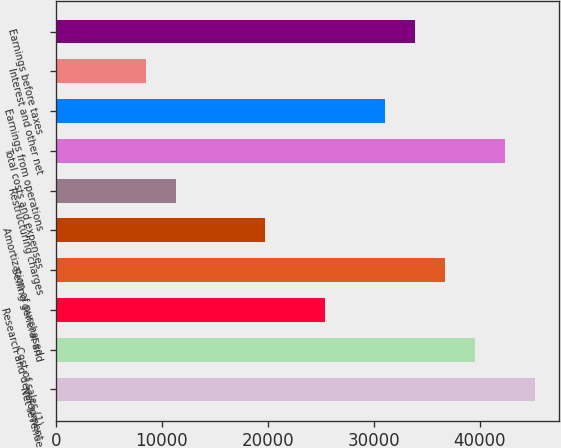Convert chart. <chart><loc_0><loc_0><loc_500><loc_500><bar_chart><fcel>Net revenue<fcel>Cost of sales (1)<fcel>Research and development<fcel>Selling general and<fcel>Amortization of purchased<fcel>Restructuring charges<fcel>Total costs and expenses<fcel>Earnings from operations<fcel>Interest and other net<fcel>Earnings before taxes<nl><fcel>45219.1<fcel>39566.7<fcel>25435.8<fcel>36740.6<fcel>19783.4<fcel>11304.8<fcel>42392.9<fcel>31088.2<fcel>8478.65<fcel>33914.4<nl></chart> 